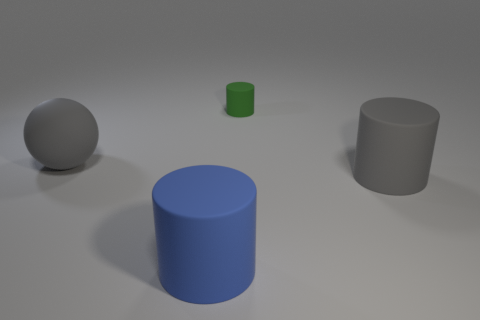Subtract all large cylinders. How many cylinders are left? 1 Add 4 blue rubber things. How many objects exist? 8 Subtract 1 cylinders. How many cylinders are left? 2 Subtract all gray cylinders. How many cylinders are left? 2 Subtract all small yellow metallic balls. Subtract all small cylinders. How many objects are left? 3 Add 3 tiny green objects. How many tiny green objects are left? 4 Add 1 large cyan metallic things. How many large cyan metallic things exist? 1 Subtract 1 gray cylinders. How many objects are left? 3 Subtract all balls. How many objects are left? 3 Subtract all brown balls. Subtract all yellow blocks. How many balls are left? 1 